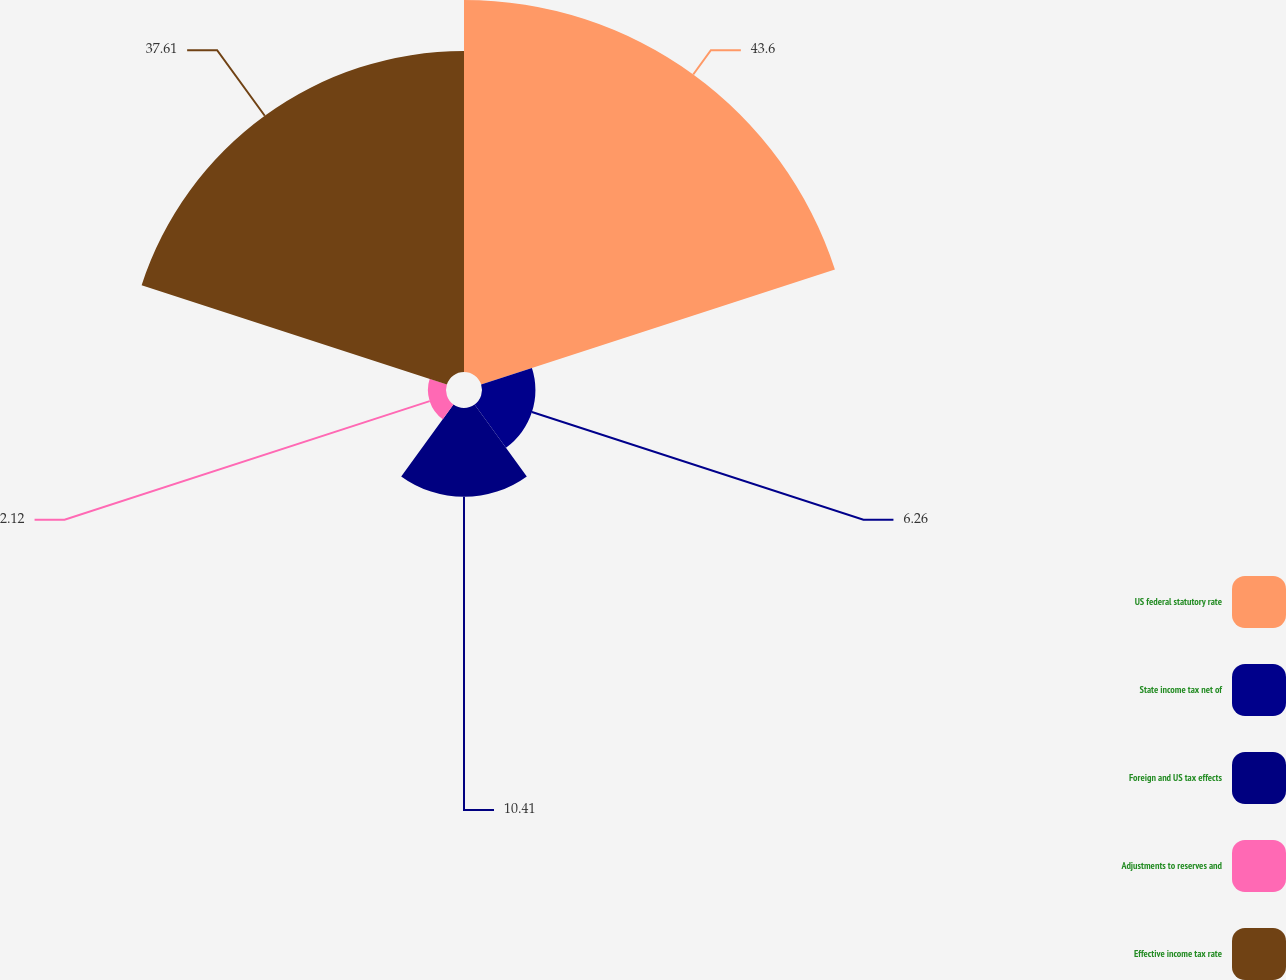<chart> <loc_0><loc_0><loc_500><loc_500><pie_chart><fcel>US federal statutory rate<fcel>State income tax net of<fcel>Foreign and US tax effects<fcel>Adjustments to reserves and<fcel>Effective income tax rate<nl><fcel>43.59%<fcel>6.26%<fcel>10.41%<fcel>2.12%<fcel>37.61%<nl></chart> 